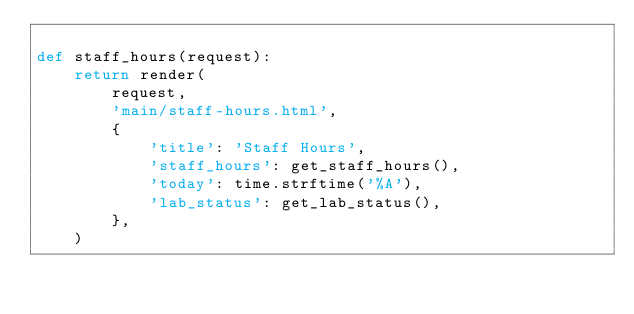<code> <loc_0><loc_0><loc_500><loc_500><_Python_>
def staff_hours(request):
    return render(
        request,
        'main/staff-hours.html',
        {
            'title': 'Staff Hours',
            'staff_hours': get_staff_hours(),
            'today': time.strftime('%A'),
            'lab_status': get_lab_status(),
        },
    )
</code> 